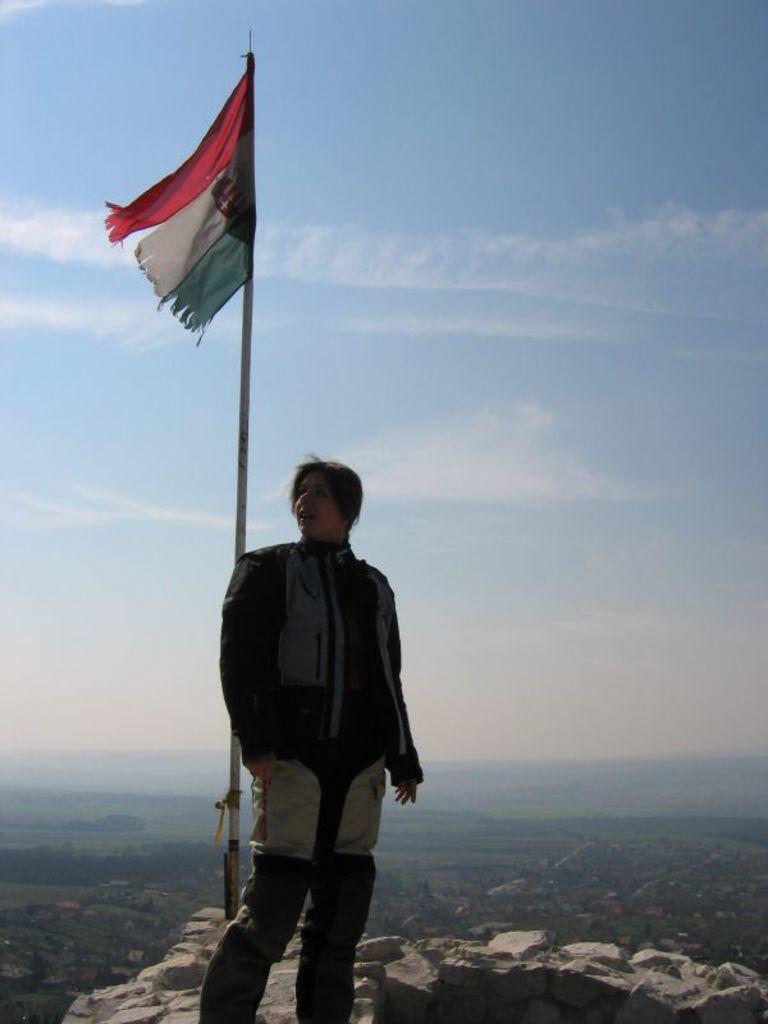How would you summarize this image in a sentence or two? In this picture we can see a woman is standing in the front, on the left side there is a flag, we can see some stones at the bottom, there is the sky at the top of the picture. 